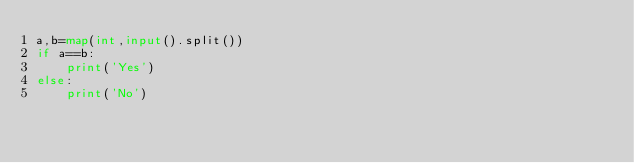<code> <loc_0><loc_0><loc_500><loc_500><_Python_>a,b=map(int,input().split())
if a==b:
    print('Yes')
else:
    print('No')</code> 